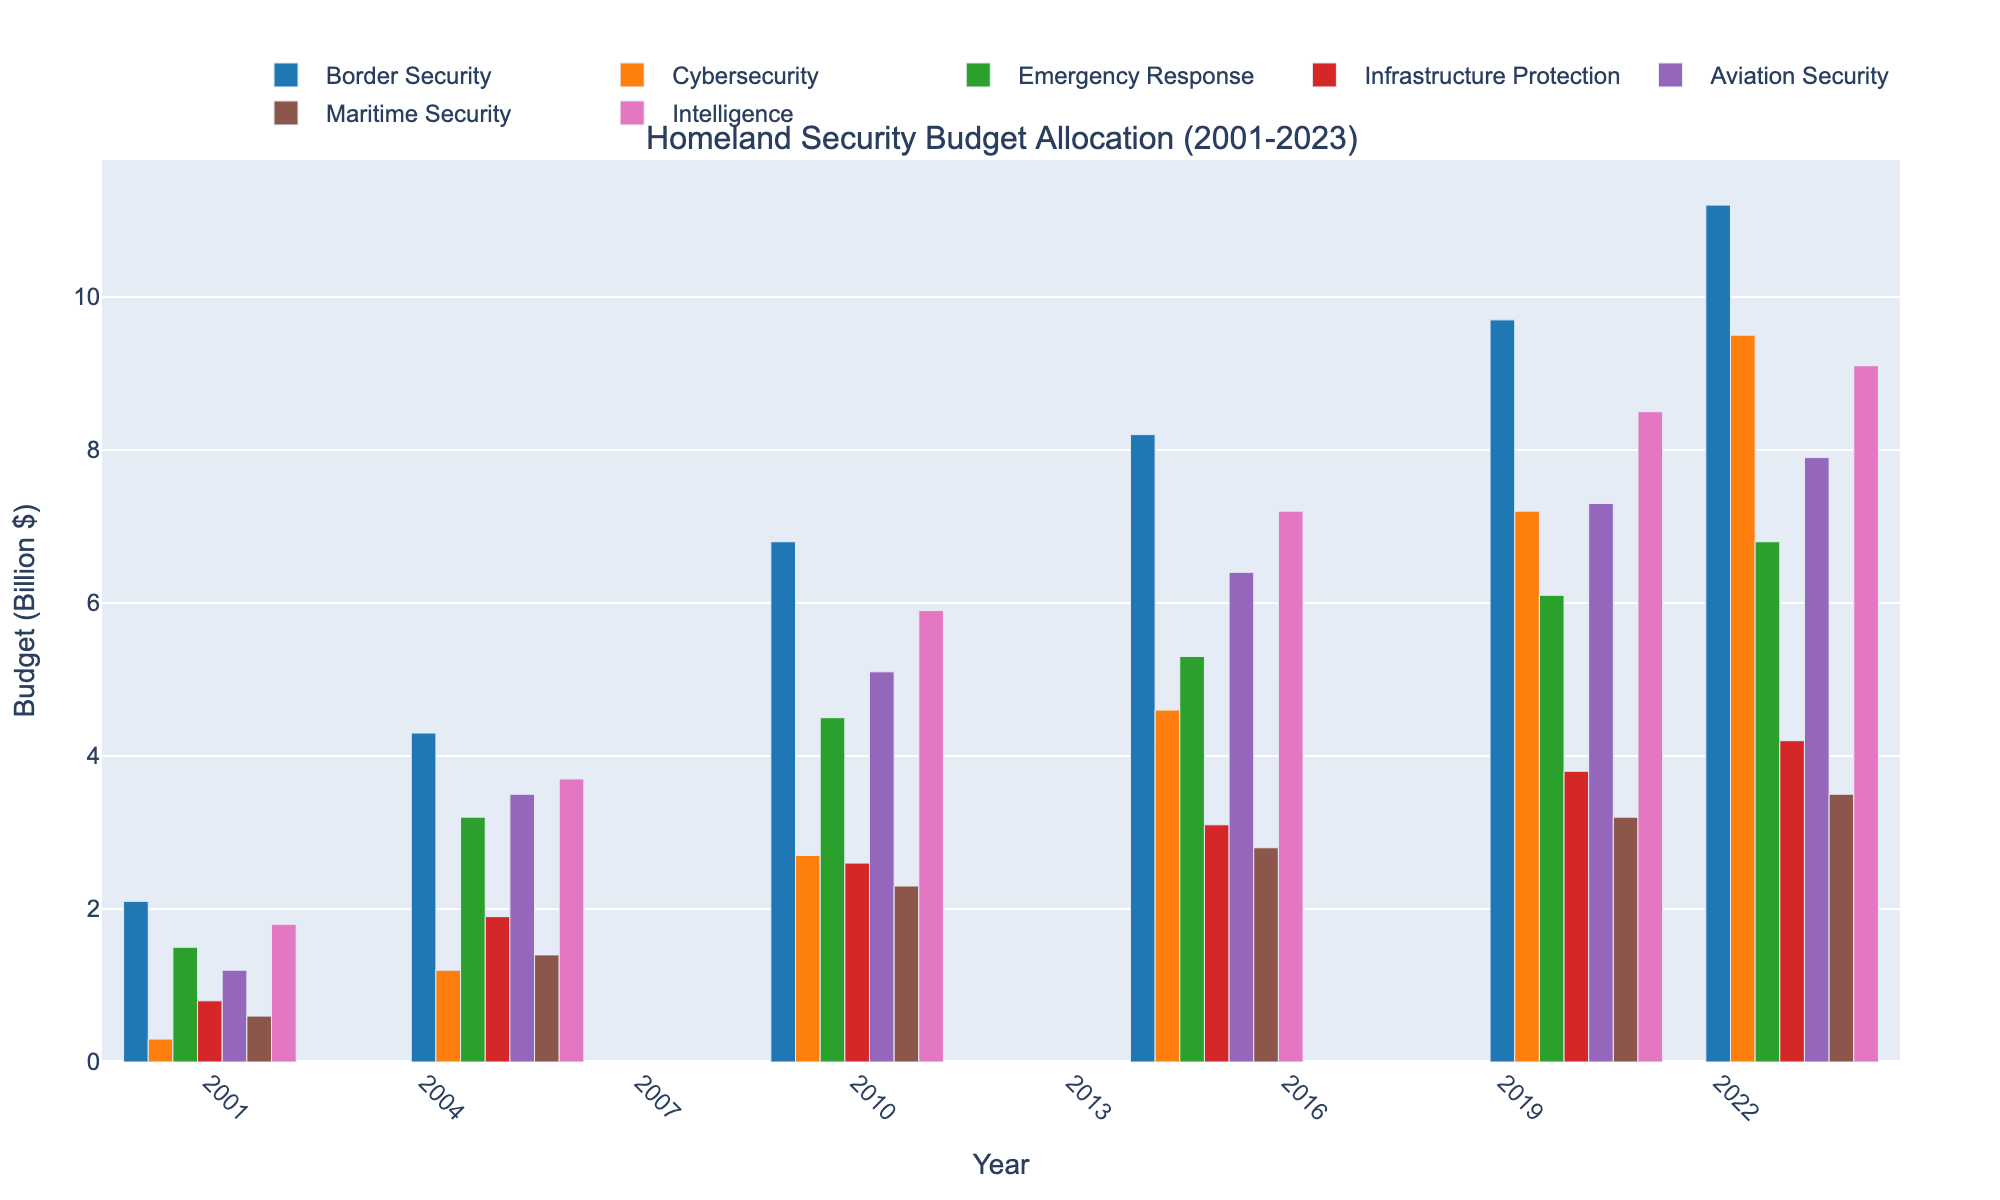What is the title of the chart? The title is located at the top of the histogram and it summarizes the visualized data.
Answer: Homeland Security Budget Allocation (2001-2023) What categories of spending are included in the figure? Categories are represented by different colored bars in the histogram; they are also mentioned in the legend.
Answer: Border Security, Cybersecurity, Emergency Response, Infrastructure Protection, Aviation Security, Maritime Security, Intelligence How much was spent on Cybersecurity in 2020? To find the answer, locate the bar corresponding to Cybersecurity for the year 2020 and read its value.
Answer: 7.2 billion dollars Which category had the highest budget allocation in 2001 and how much was it? Look at the tallest bar for the year 2001 and identify its category and value.
Answer: Intelligence, 1.8 billion dollars How has the budget for Border Security changed from 2001 to 2023? Compare the height of the Border Security bars for the years 2001 and 2023. Subtract the 2001 value from the 2023 value to find the difference.
Answer: Increased by 9.1 billion dollars Which year saw the highest spending on Intelligence and what was the amount? Identify the year corresponding to the tallest bar within the Intelligence category, then read the bar’s value.
Answer: 2023, 9.1 billion dollars What is the total budget allocation across all categories in 2015? Sum the heights of all bars for the year 2015.
Answer: 37.6 billion dollars Compare the budget for Aviation Security and Maritime Security in 2010. Which category had a higher budget and by how much? Identify the bars for Aviation Security and Maritime Security for the year 2010, compare their heights and calculate the difference.
Answer: Aviation Security was higher by 2.8 billion dollars What was the average expenditure on Emergency Response from 2001 to 2023? Sum the values for Emergency Response for all given years and divide by the number of years. (1.5+3.2+4.5+5.3+6.1+6.8)/6 = 27.4/6
Answer: 4.57 billion dollars Has the budget allocation for Cybersecurity shown a consistent increase over the recorded years? Check the heights of the Cybersecurity bars for each year to determine if the values consistently increase.
Answer: Yes 